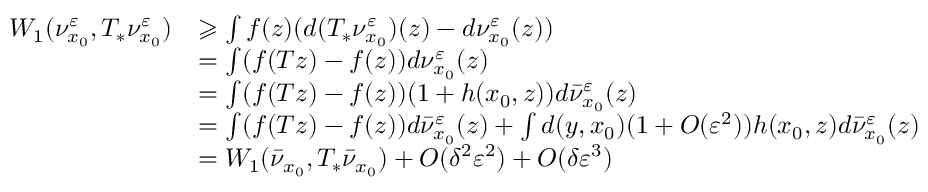Convert formula to latex. <formula><loc_0><loc_0><loc_500><loc_500>\begin{array} { r l } { W _ { 1 } ( \nu _ { x _ { 0 } } ^ { \varepsilon } , T _ { * } \nu _ { x _ { 0 } } ^ { \varepsilon } ) } & { \geqslant \int f ( z ) ( d ( T _ { * } \nu _ { x _ { 0 } } ^ { \varepsilon } ) ( z ) - d \nu _ { x _ { 0 } } ^ { \varepsilon } ( z ) ) } \\ & { = \int ( f ( T z ) - f ( z ) ) d \nu _ { x _ { 0 } } ^ { \varepsilon } ( z ) } \\ & { = \int ( f ( T z ) - f ( z ) ) ( 1 + h ( x _ { 0 } , z ) ) d \bar { \nu } _ { x _ { 0 } } ^ { \varepsilon } ( z ) } \\ & { = \int ( f ( T z ) - f ( z ) ) d \bar { \nu } _ { x _ { 0 } } ^ { \varepsilon } ( z ) + \int d ( y , x _ { 0 } ) ( 1 + O ( \varepsilon ^ { 2 } ) ) h ( x _ { 0 } , z ) d \bar { \nu } _ { x _ { 0 } } ^ { \varepsilon } ( z ) } \\ & { = W _ { 1 } ( \bar { \nu } _ { x _ { 0 } } , T _ { * } \bar { \nu } _ { x _ { 0 } } ) + O ( \delta ^ { 2 } \varepsilon ^ { 2 } ) + O ( \delta \varepsilon ^ { 3 } ) } \end{array}</formula> 